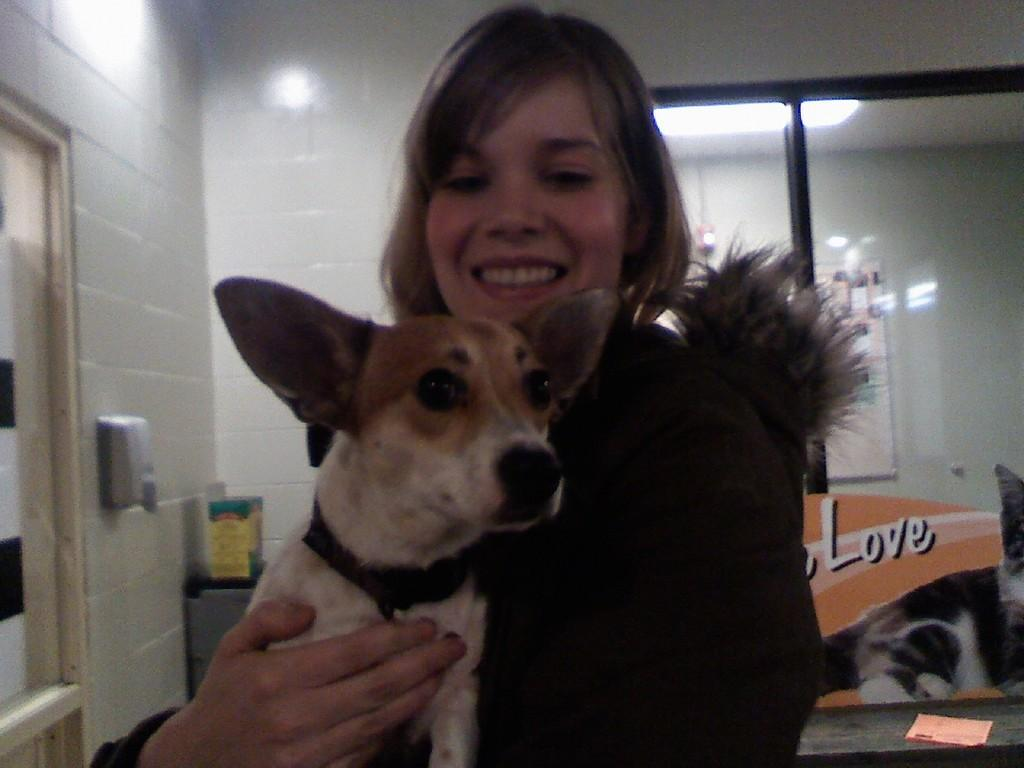What is the main subject of the image? There is a woman standing in the center of the image. What is the woman holding in the image? The woman is holding a dog. What can be seen in the background of the image? There is a wall, a window, and some objects visible in the background of the image. What does the caption say about the girls in the image? There is no caption present in the image, and it does not depict any girls. 